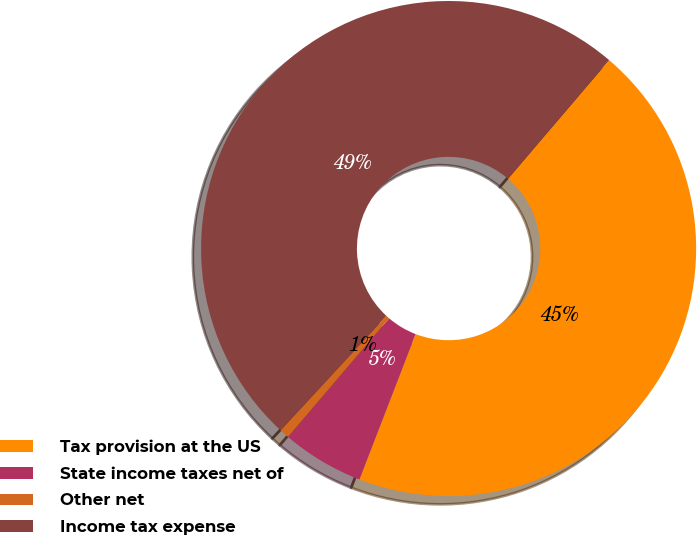Convert chart. <chart><loc_0><loc_0><loc_500><loc_500><pie_chart><fcel>Tax provision at the US<fcel>State income taxes net of<fcel>Other net<fcel>Income tax expense<nl><fcel>44.63%<fcel>5.37%<fcel>0.64%<fcel>49.36%<nl></chart> 